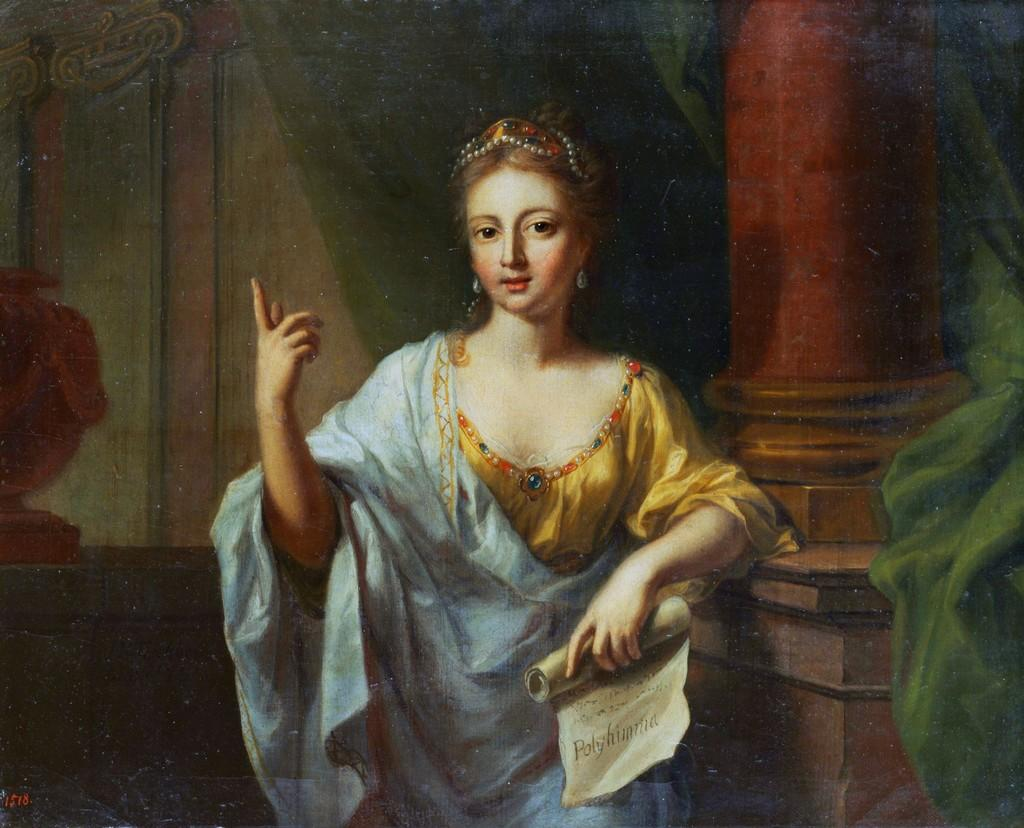What type of artwork is depicted in the image? The image is a painting. What is the person in the painting doing? The person is standing and holding a paper. What can be seen in the background of the painting? There is a pot and a pillar in the background of the painting. What type of harbor can be seen in the painting? There is no harbor present in the painting; it features a person standing with a paper, a pot, and a pillar in the background. 